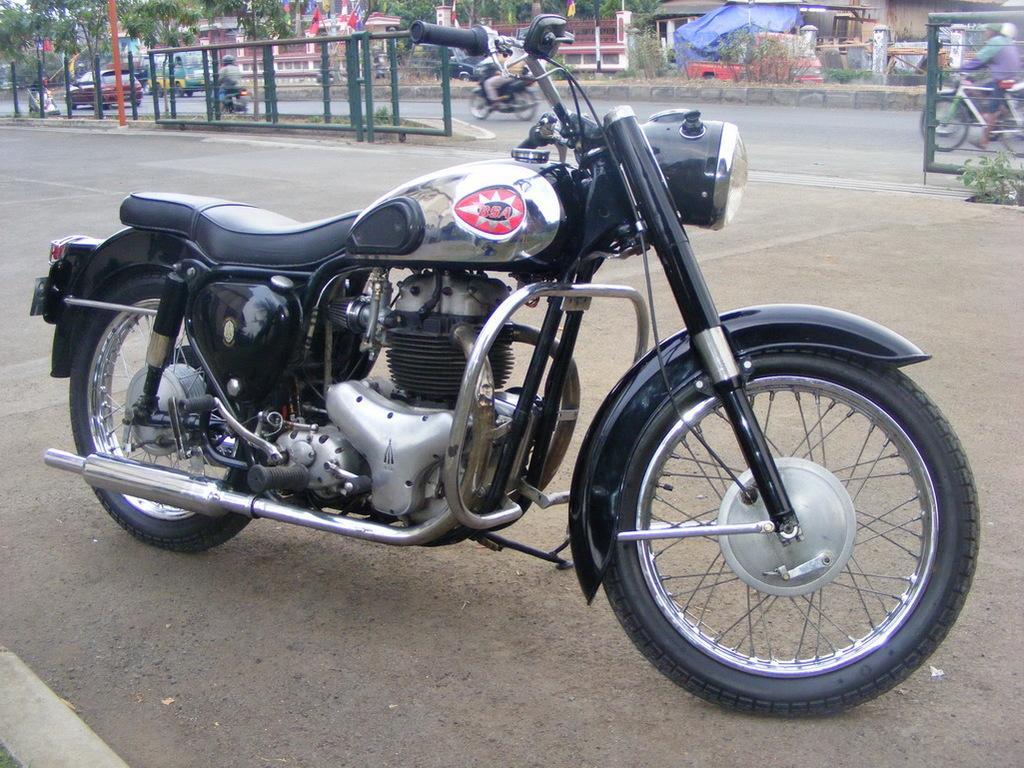Please provide a concise description of this image. In this image I can see the motorbike which is in black and silver color. It is on the road. To the side I can see the railing and few people riding the bikes and bicycles and also I can see few vehicles. To the side of the road I can see many trees, buildings and also poles. 